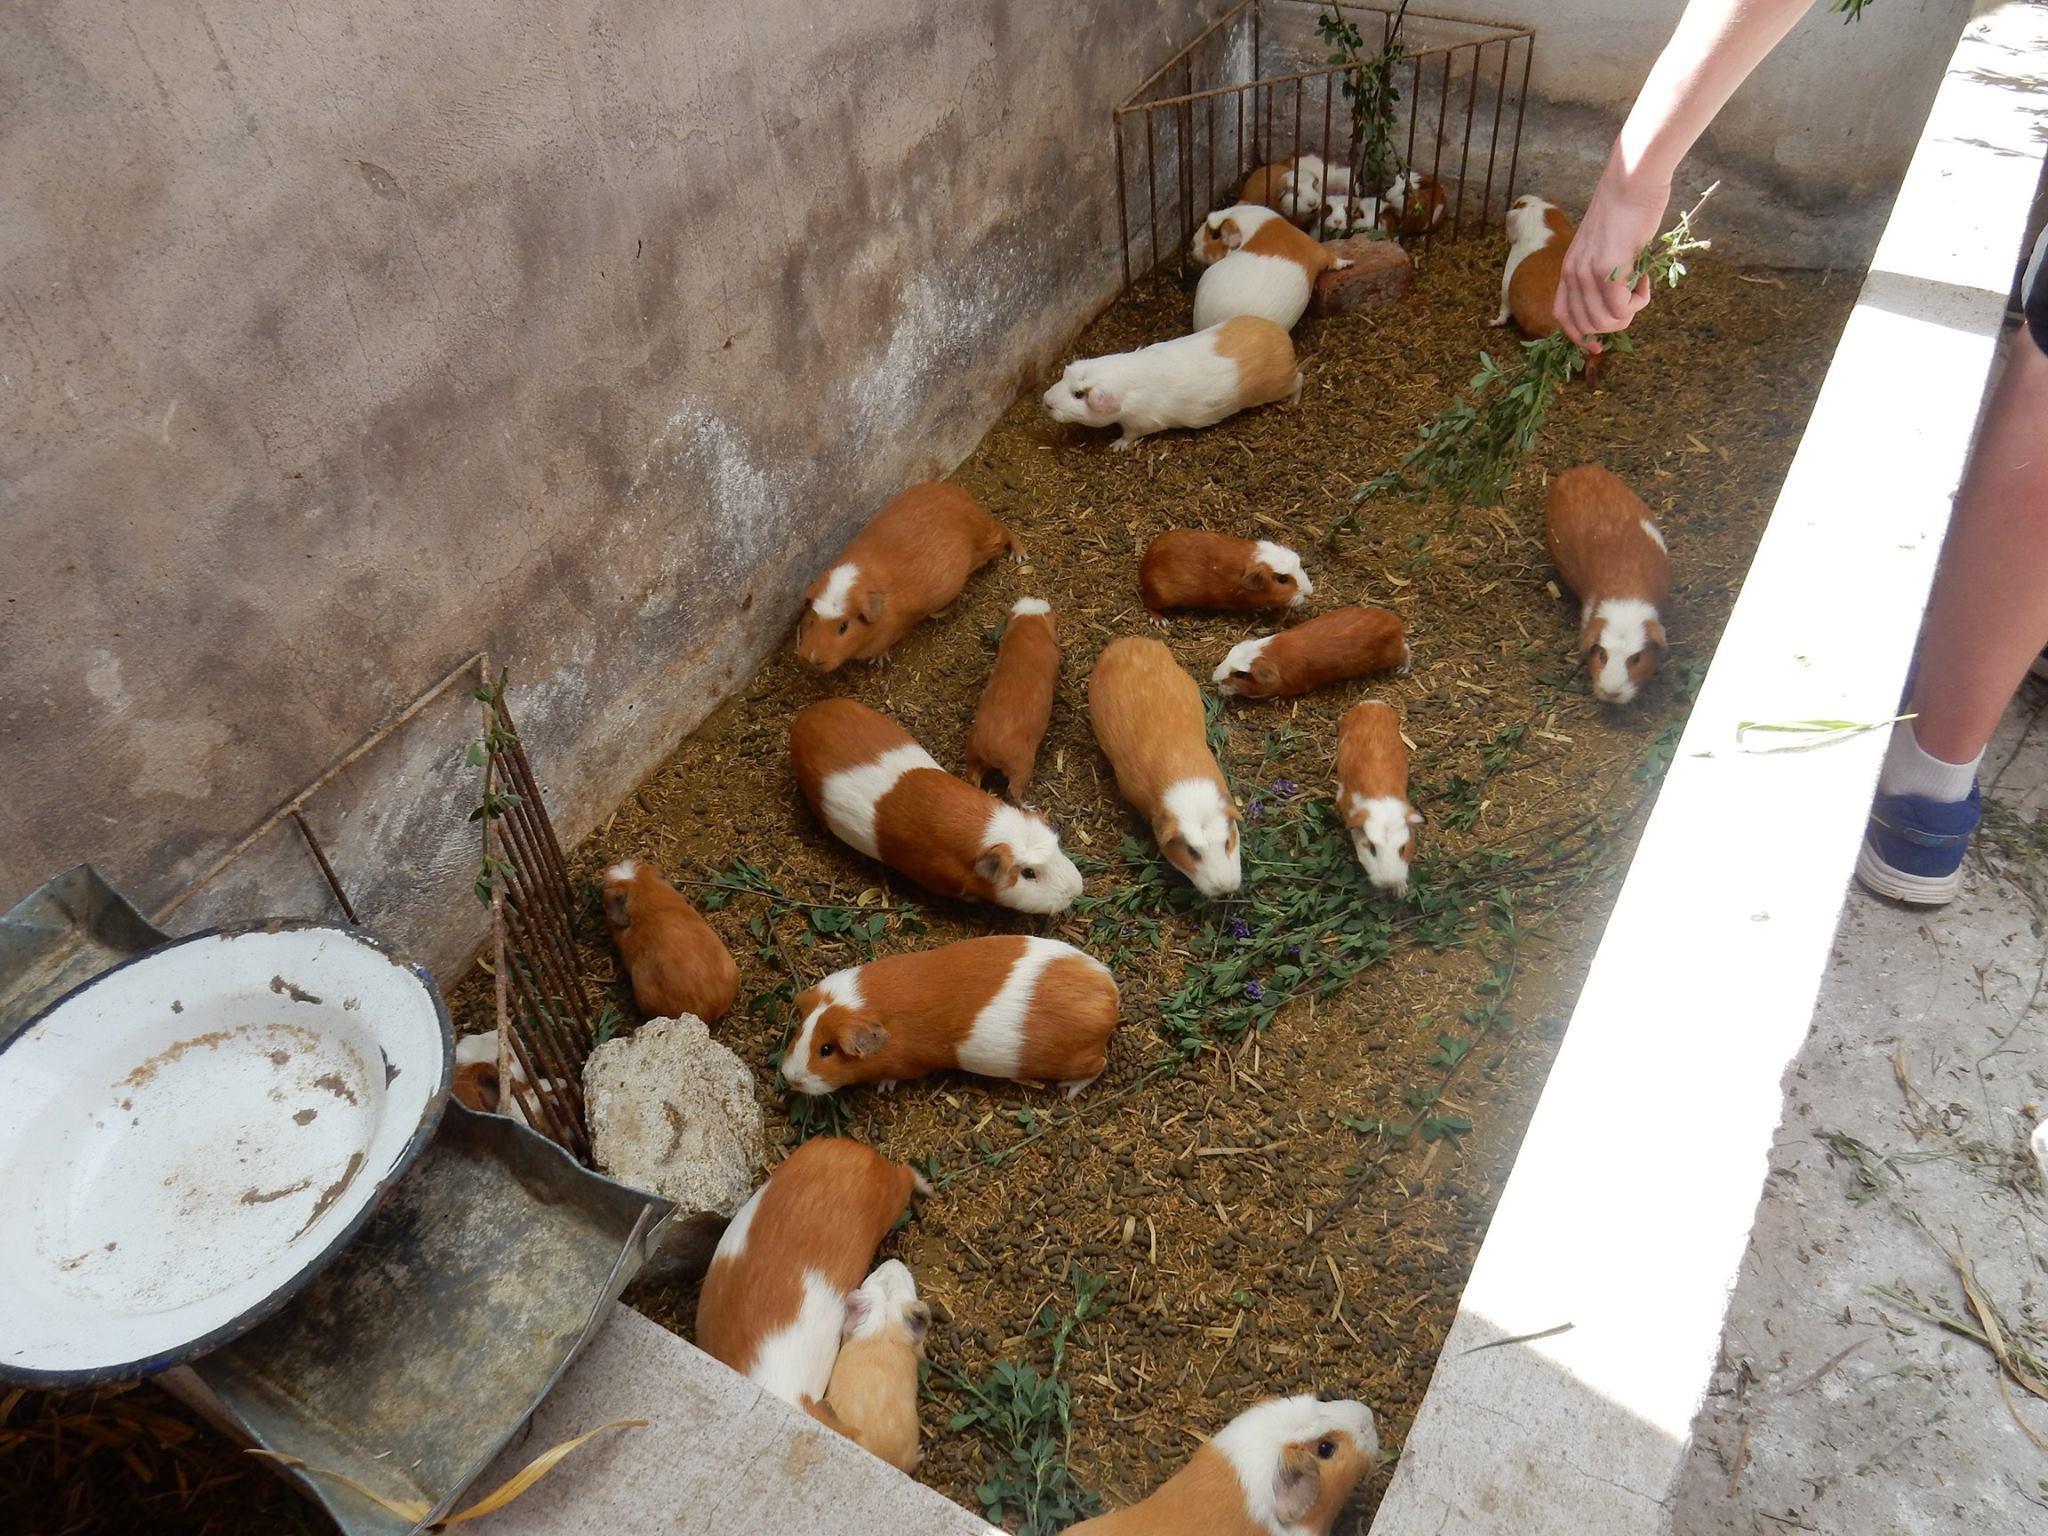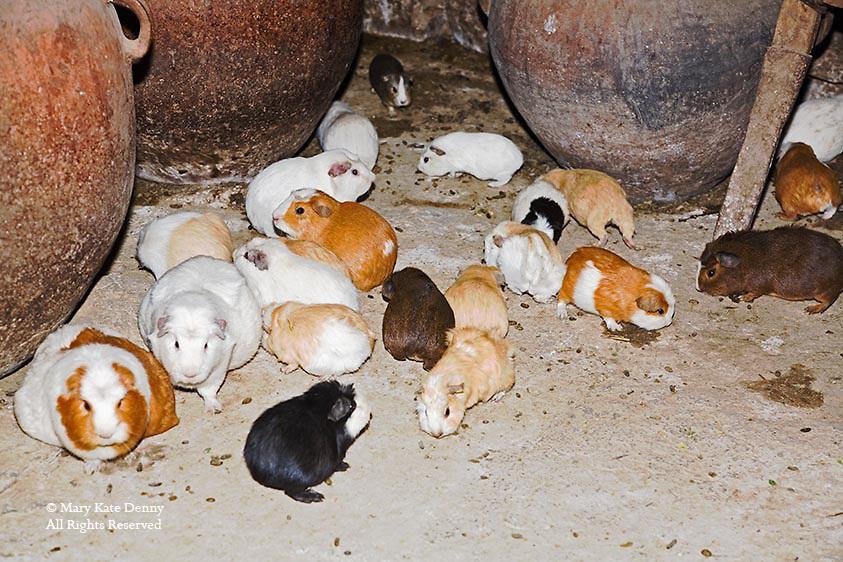The first image is the image on the left, the second image is the image on the right. For the images shown, is this caption "There is a total of 1 guinea pig being displayed with flowers." true? Answer yes or no. No. The first image is the image on the left, the second image is the image on the right. Examine the images to the left and right. Is the description "there are numerous guinea pigs housed in a concrete pen" accurate? Answer yes or no. Yes. 